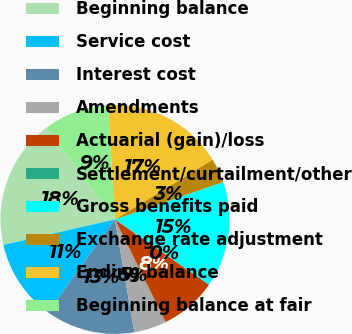Convert chart. <chart><loc_0><loc_0><loc_500><loc_500><pie_chart><fcel>Beginning balance<fcel>Service cost<fcel>Interest cost<fcel>Amendments<fcel>Actuarial (gain)/loss<fcel>Settlement/curtailment/other<fcel>Gross benefits paid<fcel>Exchange rate adjustment<fcel>Ending balance<fcel>Beginning balance at fair<nl><fcel>18.39%<fcel>11.49%<fcel>12.64%<fcel>4.6%<fcel>8.05%<fcel>0.0%<fcel>14.94%<fcel>3.45%<fcel>17.24%<fcel>9.2%<nl></chart> 